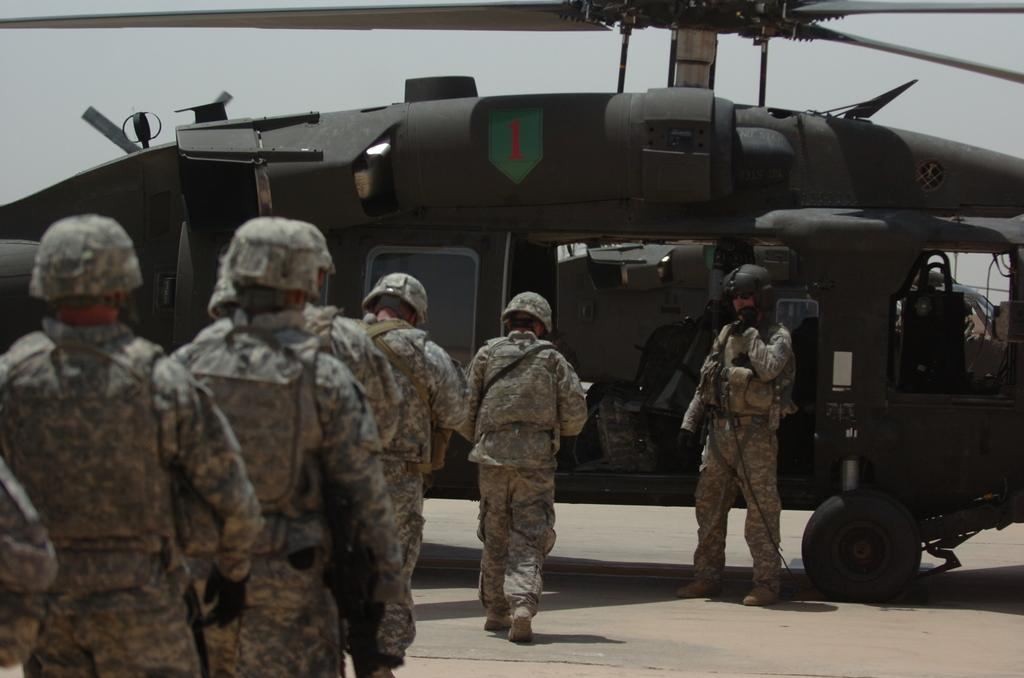What type of people are present in the image? There are soldiers in the image. What are the soldiers doing in the image? The soldiers are walking and boarding a helicopter. Can you describe the helicopter in the image? The helicopter is brown in color. What type of love can be seen between the soldiers in the image? There is no indication of love between the soldiers in the image; they are focused on their tasks. 